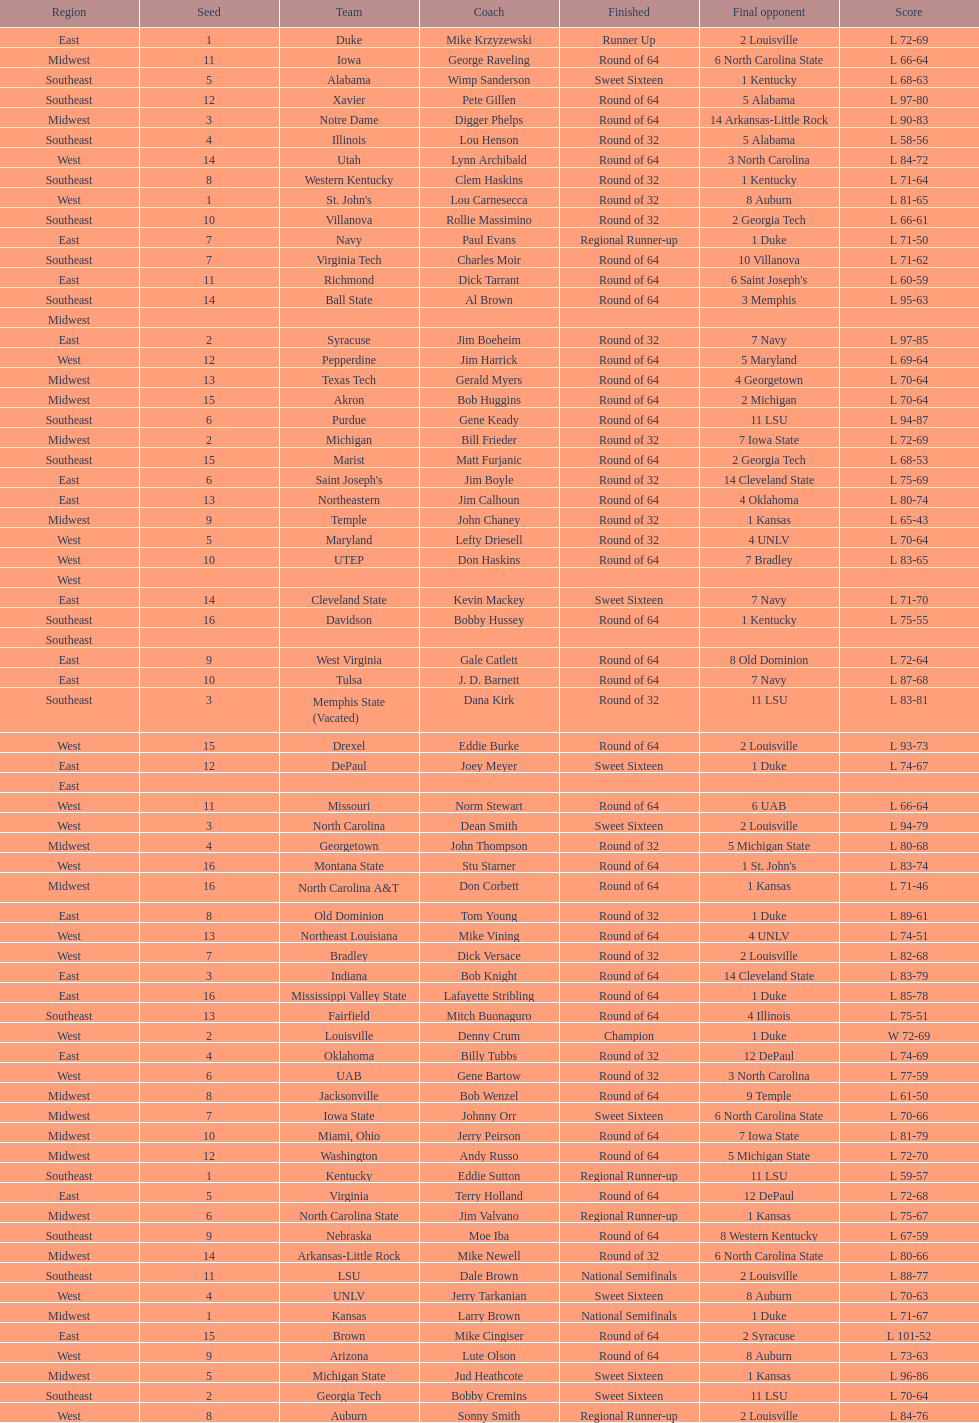How many 1 seeds are there? 4. 